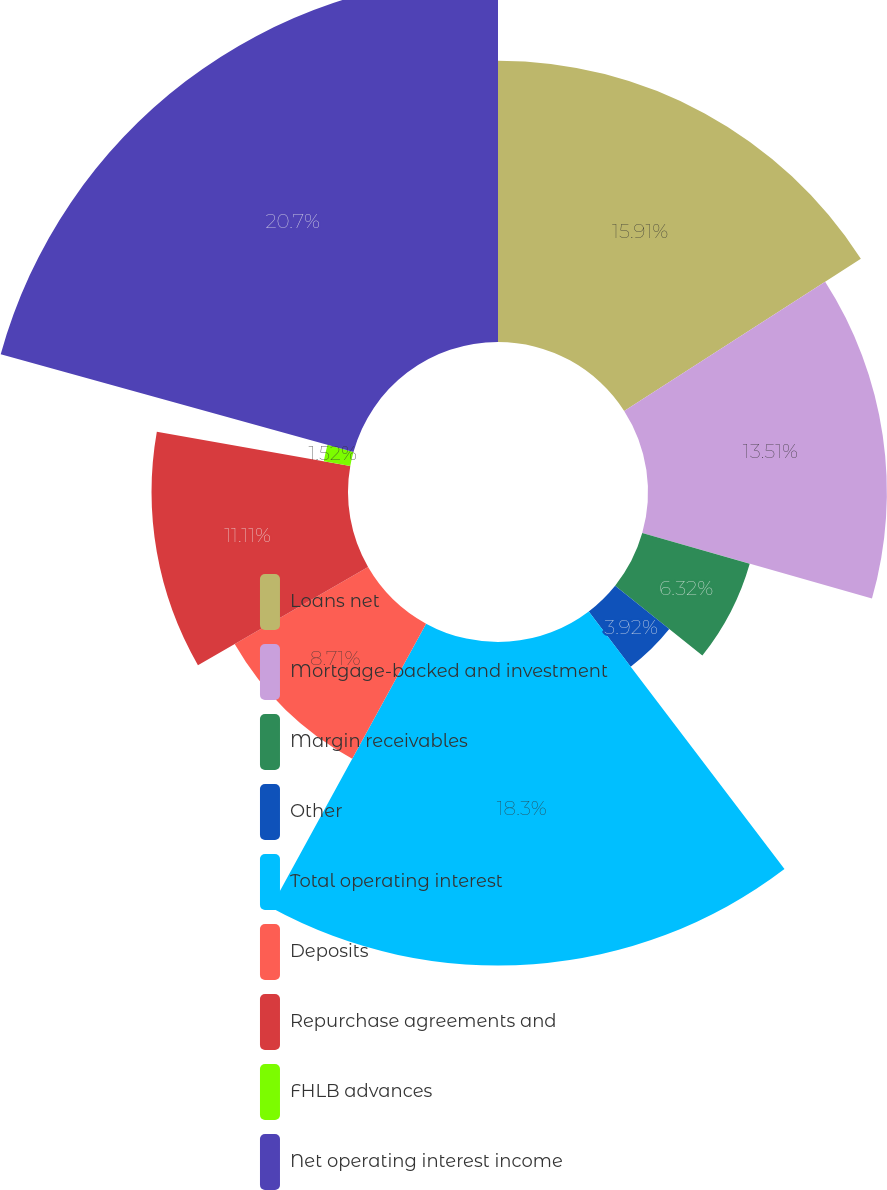<chart> <loc_0><loc_0><loc_500><loc_500><pie_chart><fcel>Loans net<fcel>Mortgage-backed and investment<fcel>Margin receivables<fcel>Other<fcel>Total operating interest<fcel>Deposits<fcel>Repurchase agreements and<fcel>FHLB advances<fcel>Net operating interest income<nl><fcel>15.91%<fcel>13.51%<fcel>6.32%<fcel>3.92%<fcel>18.3%<fcel>8.71%<fcel>11.11%<fcel>1.52%<fcel>20.7%<nl></chart> 